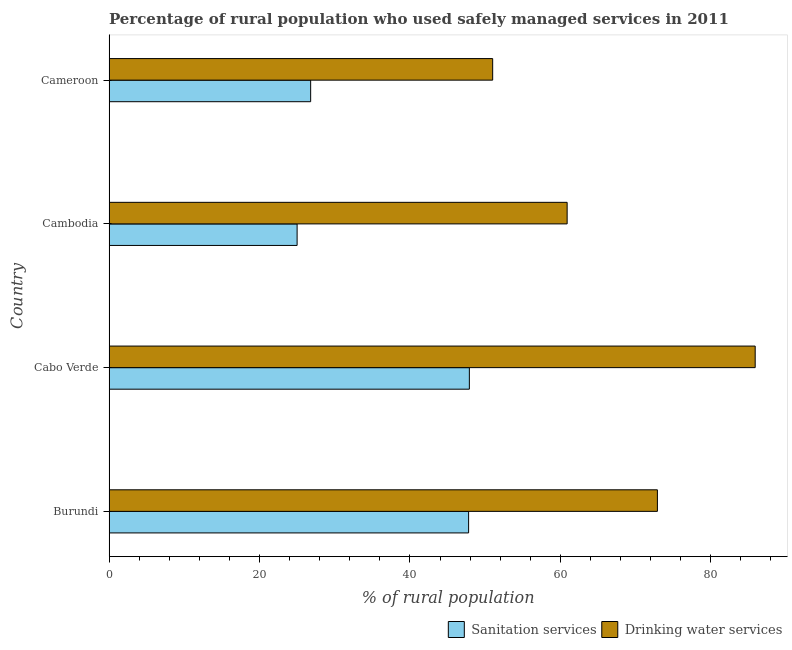How many different coloured bars are there?
Ensure brevity in your answer.  2. How many groups of bars are there?
Provide a short and direct response. 4. Are the number of bars per tick equal to the number of legend labels?
Offer a very short reply. Yes. How many bars are there on the 4th tick from the top?
Your answer should be very brief. 2. How many bars are there on the 4th tick from the bottom?
Give a very brief answer. 2. What is the label of the 3rd group of bars from the top?
Give a very brief answer. Cabo Verde. In how many cases, is the number of bars for a given country not equal to the number of legend labels?
Offer a terse response. 0. What is the percentage of rural population who used sanitation services in Cabo Verde?
Your response must be concise. 47.9. Across all countries, what is the maximum percentage of rural population who used sanitation services?
Your response must be concise. 47.9. In which country was the percentage of rural population who used sanitation services maximum?
Provide a short and direct response. Cabo Verde. In which country was the percentage of rural population who used sanitation services minimum?
Offer a terse response. Cambodia. What is the total percentage of rural population who used sanitation services in the graph?
Make the answer very short. 147.5. What is the difference between the percentage of rural population who used sanitation services in Burundi and that in Cabo Verde?
Offer a very short reply. -0.1. What is the difference between the percentage of rural population who used sanitation services in Burundi and the percentage of rural population who used drinking water services in Cambodia?
Your answer should be compact. -13.1. What is the average percentage of rural population who used drinking water services per country?
Give a very brief answer. 67.67. What is the difference between the percentage of rural population who used sanitation services and percentage of rural population who used drinking water services in Cambodia?
Offer a terse response. -35.9. In how many countries, is the percentage of rural population who used sanitation services greater than 72 %?
Provide a succinct answer. 0. What is the ratio of the percentage of rural population who used drinking water services in Cabo Verde to that in Cambodia?
Provide a succinct answer. 1.41. Is the percentage of rural population who used sanitation services in Cambodia less than that in Cameroon?
Offer a very short reply. Yes. What is the difference between the highest and the second highest percentage of rural population who used drinking water services?
Your response must be concise. 13. What is the difference between the highest and the lowest percentage of rural population who used sanitation services?
Ensure brevity in your answer.  22.9. Is the sum of the percentage of rural population who used drinking water services in Cambodia and Cameroon greater than the maximum percentage of rural population who used sanitation services across all countries?
Give a very brief answer. Yes. What does the 2nd bar from the top in Cambodia represents?
Your response must be concise. Sanitation services. What does the 1st bar from the bottom in Cambodia represents?
Your response must be concise. Sanitation services. How many bars are there?
Give a very brief answer. 8. Are all the bars in the graph horizontal?
Your answer should be very brief. Yes. What is the difference between two consecutive major ticks on the X-axis?
Offer a terse response. 20. Are the values on the major ticks of X-axis written in scientific E-notation?
Your response must be concise. No. Does the graph contain any zero values?
Offer a very short reply. No. Where does the legend appear in the graph?
Provide a short and direct response. Bottom right. How many legend labels are there?
Provide a succinct answer. 2. How are the legend labels stacked?
Your answer should be very brief. Horizontal. What is the title of the graph?
Your answer should be very brief. Percentage of rural population who used safely managed services in 2011. What is the label or title of the X-axis?
Your answer should be compact. % of rural population. What is the label or title of the Y-axis?
Your answer should be compact. Country. What is the % of rural population in Sanitation services in Burundi?
Give a very brief answer. 47.8. What is the % of rural population in Drinking water services in Burundi?
Keep it short and to the point. 72.9. What is the % of rural population of Sanitation services in Cabo Verde?
Your answer should be compact. 47.9. What is the % of rural population of Drinking water services in Cabo Verde?
Offer a very short reply. 85.9. What is the % of rural population of Drinking water services in Cambodia?
Your answer should be very brief. 60.9. What is the % of rural population of Sanitation services in Cameroon?
Offer a terse response. 26.8. What is the % of rural population of Drinking water services in Cameroon?
Keep it short and to the point. 51. Across all countries, what is the maximum % of rural population of Sanitation services?
Keep it short and to the point. 47.9. Across all countries, what is the maximum % of rural population in Drinking water services?
Ensure brevity in your answer.  85.9. Across all countries, what is the minimum % of rural population in Sanitation services?
Your answer should be very brief. 25. What is the total % of rural population of Sanitation services in the graph?
Your answer should be very brief. 147.5. What is the total % of rural population of Drinking water services in the graph?
Your answer should be compact. 270.7. What is the difference between the % of rural population in Drinking water services in Burundi and that in Cabo Verde?
Provide a short and direct response. -13. What is the difference between the % of rural population in Sanitation services in Burundi and that in Cambodia?
Make the answer very short. 22.8. What is the difference between the % of rural population of Drinking water services in Burundi and that in Cameroon?
Your answer should be very brief. 21.9. What is the difference between the % of rural population in Sanitation services in Cabo Verde and that in Cambodia?
Your answer should be very brief. 22.9. What is the difference between the % of rural population in Sanitation services in Cabo Verde and that in Cameroon?
Ensure brevity in your answer.  21.1. What is the difference between the % of rural population of Drinking water services in Cabo Verde and that in Cameroon?
Make the answer very short. 34.9. What is the difference between the % of rural population of Sanitation services in Cambodia and that in Cameroon?
Give a very brief answer. -1.8. What is the difference between the % of rural population in Sanitation services in Burundi and the % of rural population in Drinking water services in Cabo Verde?
Your answer should be very brief. -38.1. What is the difference between the % of rural population in Sanitation services in Burundi and the % of rural population in Drinking water services in Cambodia?
Provide a short and direct response. -13.1. What is the difference between the % of rural population in Sanitation services in Cabo Verde and the % of rural population in Drinking water services in Cambodia?
Offer a terse response. -13. What is the difference between the % of rural population of Sanitation services in Cabo Verde and the % of rural population of Drinking water services in Cameroon?
Your answer should be compact. -3.1. What is the difference between the % of rural population in Sanitation services in Cambodia and the % of rural population in Drinking water services in Cameroon?
Offer a terse response. -26. What is the average % of rural population of Sanitation services per country?
Make the answer very short. 36.88. What is the average % of rural population in Drinking water services per country?
Your answer should be very brief. 67.67. What is the difference between the % of rural population in Sanitation services and % of rural population in Drinking water services in Burundi?
Your answer should be compact. -25.1. What is the difference between the % of rural population in Sanitation services and % of rural population in Drinking water services in Cabo Verde?
Ensure brevity in your answer.  -38. What is the difference between the % of rural population of Sanitation services and % of rural population of Drinking water services in Cambodia?
Provide a short and direct response. -35.9. What is the difference between the % of rural population of Sanitation services and % of rural population of Drinking water services in Cameroon?
Your answer should be very brief. -24.2. What is the ratio of the % of rural population of Sanitation services in Burundi to that in Cabo Verde?
Provide a short and direct response. 1. What is the ratio of the % of rural population of Drinking water services in Burundi to that in Cabo Verde?
Make the answer very short. 0.85. What is the ratio of the % of rural population in Sanitation services in Burundi to that in Cambodia?
Offer a very short reply. 1.91. What is the ratio of the % of rural population in Drinking water services in Burundi to that in Cambodia?
Your response must be concise. 1.2. What is the ratio of the % of rural population in Sanitation services in Burundi to that in Cameroon?
Give a very brief answer. 1.78. What is the ratio of the % of rural population in Drinking water services in Burundi to that in Cameroon?
Offer a terse response. 1.43. What is the ratio of the % of rural population in Sanitation services in Cabo Verde to that in Cambodia?
Offer a very short reply. 1.92. What is the ratio of the % of rural population in Drinking water services in Cabo Verde to that in Cambodia?
Ensure brevity in your answer.  1.41. What is the ratio of the % of rural population of Sanitation services in Cabo Verde to that in Cameroon?
Provide a short and direct response. 1.79. What is the ratio of the % of rural population of Drinking water services in Cabo Verde to that in Cameroon?
Offer a terse response. 1.68. What is the ratio of the % of rural population of Sanitation services in Cambodia to that in Cameroon?
Offer a terse response. 0.93. What is the ratio of the % of rural population in Drinking water services in Cambodia to that in Cameroon?
Provide a succinct answer. 1.19. What is the difference between the highest and the second highest % of rural population in Drinking water services?
Your answer should be very brief. 13. What is the difference between the highest and the lowest % of rural population in Sanitation services?
Your response must be concise. 22.9. What is the difference between the highest and the lowest % of rural population of Drinking water services?
Offer a terse response. 34.9. 